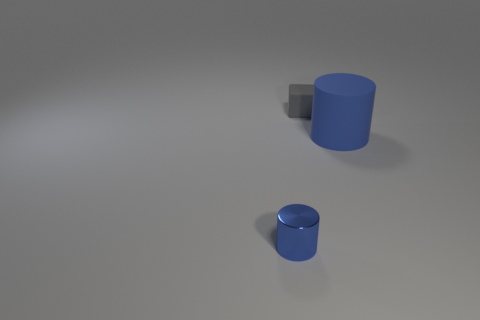Add 2 blue cylinders. How many objects exist? 5 Subtract all cylinders. How many objects are left? 1 Add 2 small cubes. How many small cubes are left? 3 Add 3 small gray objects. How many small gray objects exist? 4 Subtract 0 red spheres. How many objects are left? 3 Subtract all large rubber cylinders. Subtract all small gray rubber blocks. How many objects are left? 1 